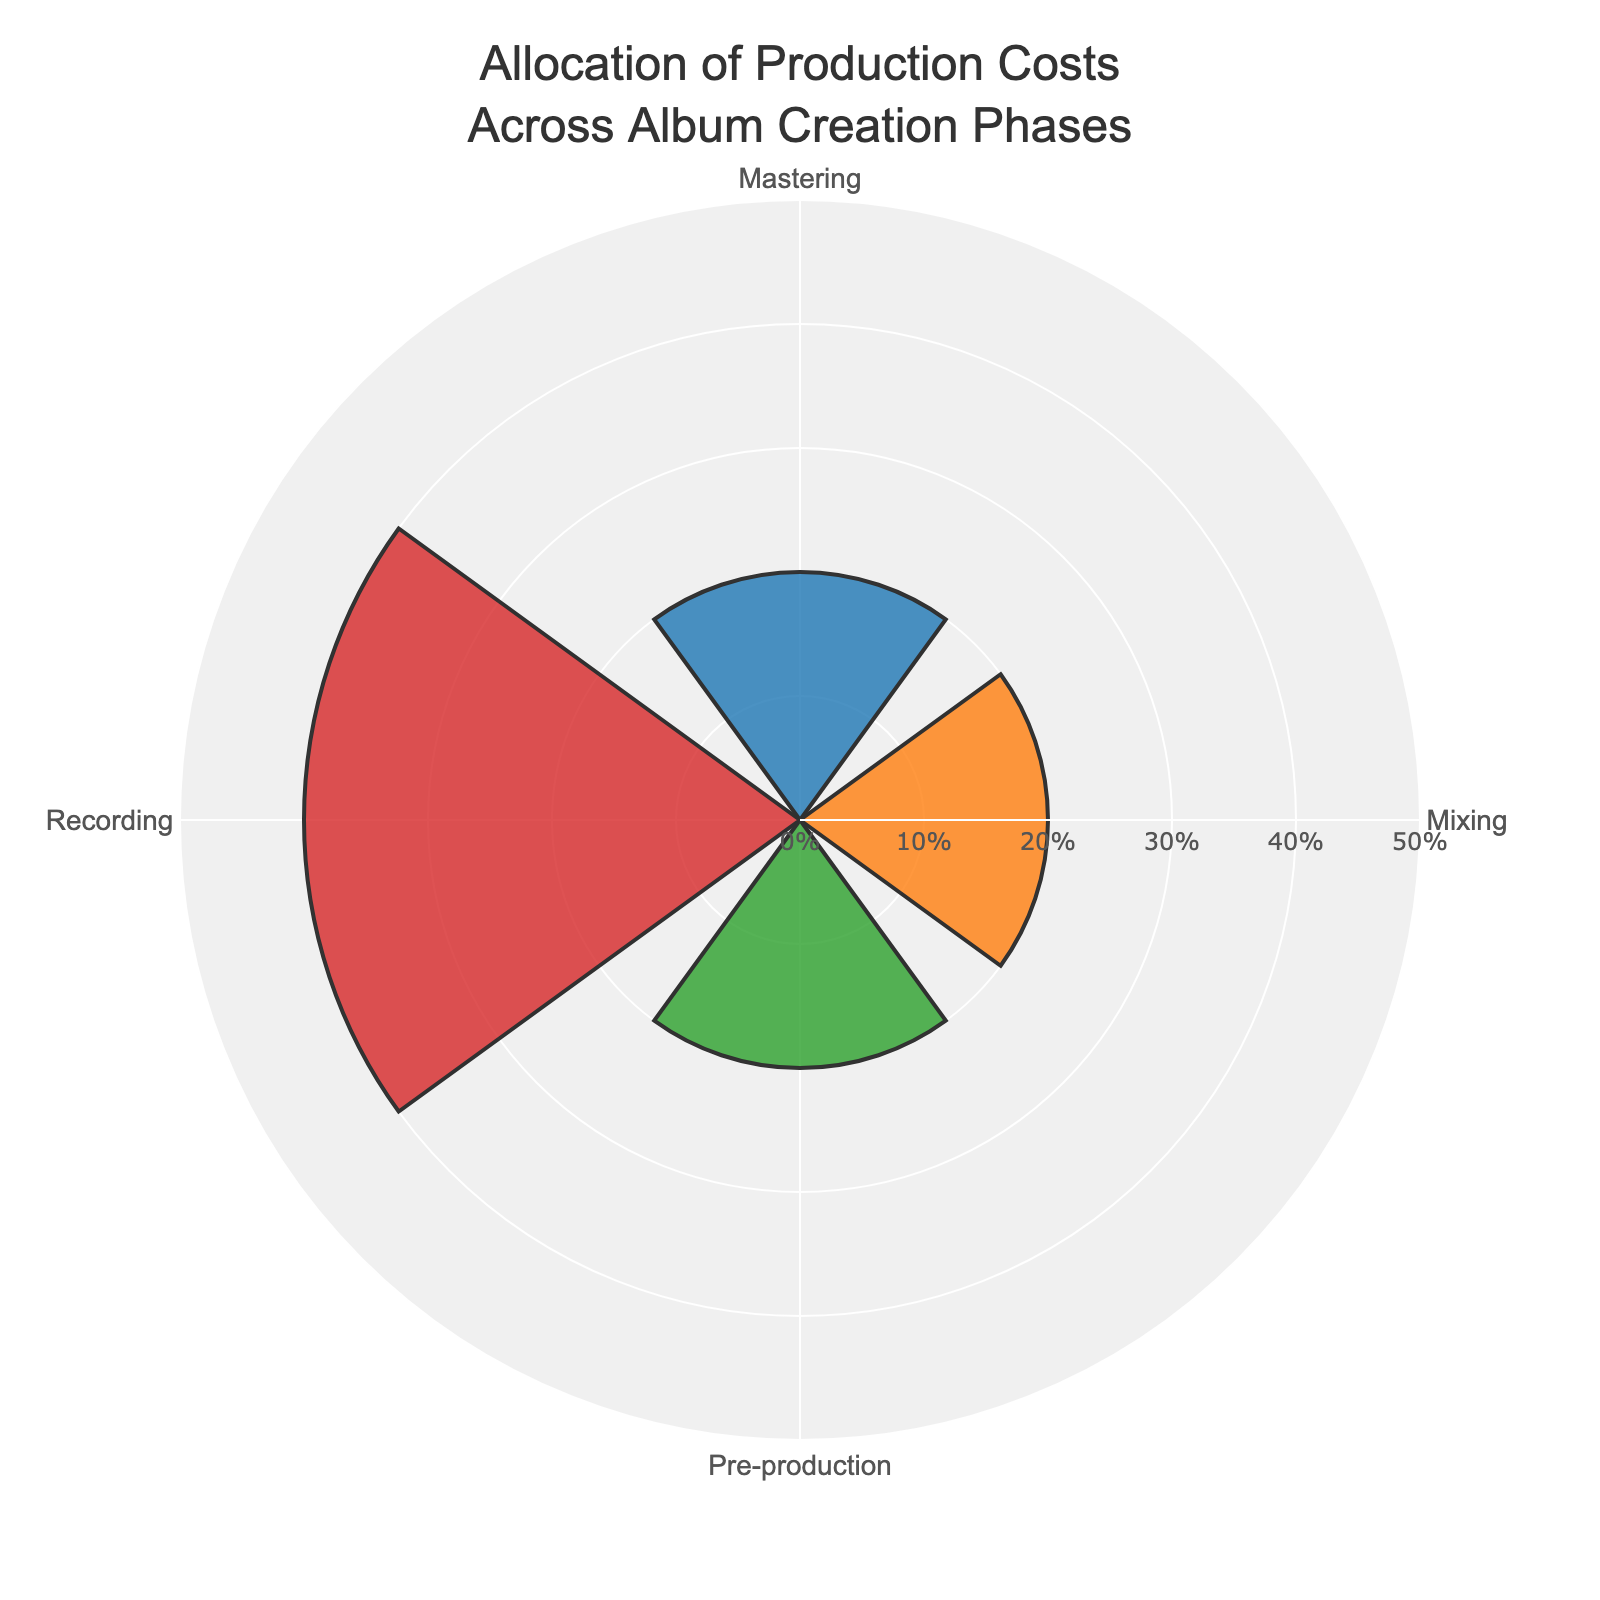What's the title of the chart? The title is prominently displayed at the top of the chart, typically larger and bolder than other text. The title is "Allocation of Production Costs Across Album Creation Phases".
Answer: Allocation of Production Costs Across Album Creation Phases Which phase has the highest cost allocation? By looking at the radial values in the polar area chart, the phase with the lengthiest bar (indicating the highest percentage) is "Recording".
Answer: Recording What's the total allocation percentage for the Mixing phase? To find this, sum up all individual allocation percentages for the Mixing phase in the chart. The chart indicates that Mixing Engineer Fees is 15% and Additional Studio Time is 5%, together summing to 20%.
Answer: 20% How does the allocation percentage for Pre-production compare to Mastering? You can visually compare the heights of the bars for Pre-production and Mastering. Adding up the Pre-production costs (10%+5%+5%) gives 20%, while Mastering (10%+10%) also sums to 20%. They are equal.
Answer: They are equal Which phase has the lowest cost allocation? Identify the smallest bar in the chart, indicating the phase with the lowest total percentage allocated. The lowest allocation is for "Pre-production".
Answer: Pre-production What is the difference between the allocation percentages for Recording and Mixing? Sum up the percentages for each phase and then subtract the two totals. Recording has 20% (Studio Rental) + 10% (Equipment Hire) + 5% (Session Musician Fees) + 5% (Engineering Fees) = 40%. Mixing has 15% (Mixing Engineer Fees) + 5% (Additional Studio Time) = 20%. The difference is 40% - 20% = 20%.
Answer: 20% What's the combined allocation for pre and post-production costs? Sum the total allocations for both Pre-production and Mastering phases. Pre-production is 20%, and Mastering is 20%. Combined, they sum up to 40%.
Answer: 40% Which individual allocation has the highest percentage? Identify the single bar with the lengthiest radius in the chart, representing the highest individual allocation. The highest allocation is "Studio Rental" during the Recording phase at 20%.
Answer: Studio Rental in Recording (20%) What's the average allocation percentage for all phases? Sum all the allocation percentages and divide by the number of phases (4). Total sum: 20% (Pre-production) + 40% (Recording) + 20% (Mixing) + 20% (Mastering) = 100%. There are 4 phases. Average = 100% / 4 = 25%.
Answer: 25% 